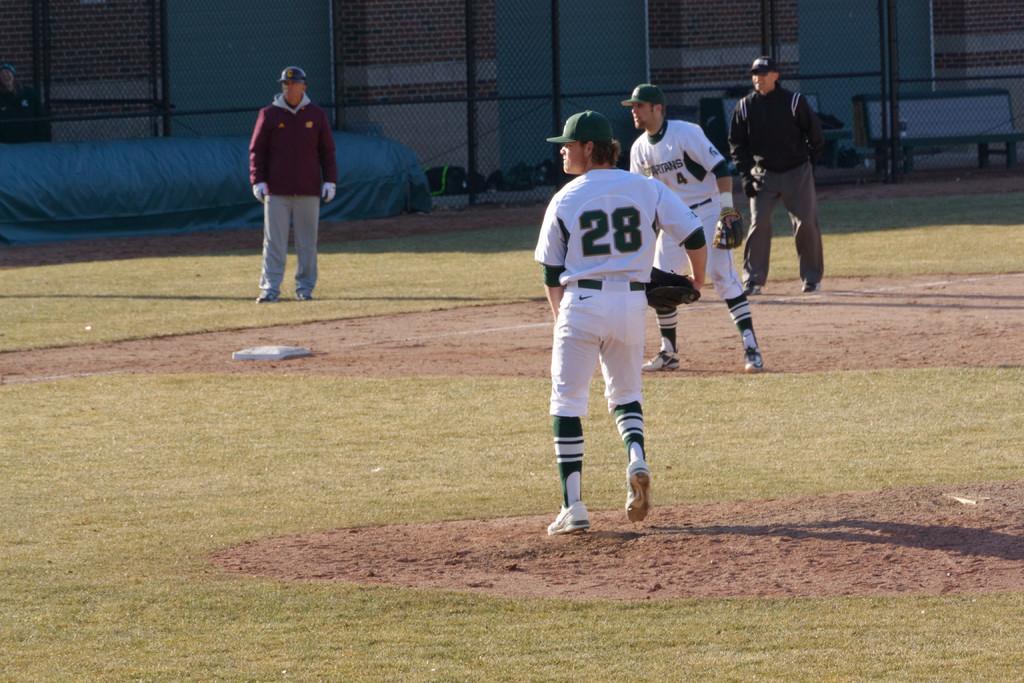What number is the player who isn't on the pitcher's mound?
Ensure brevity in your answer.  4. 